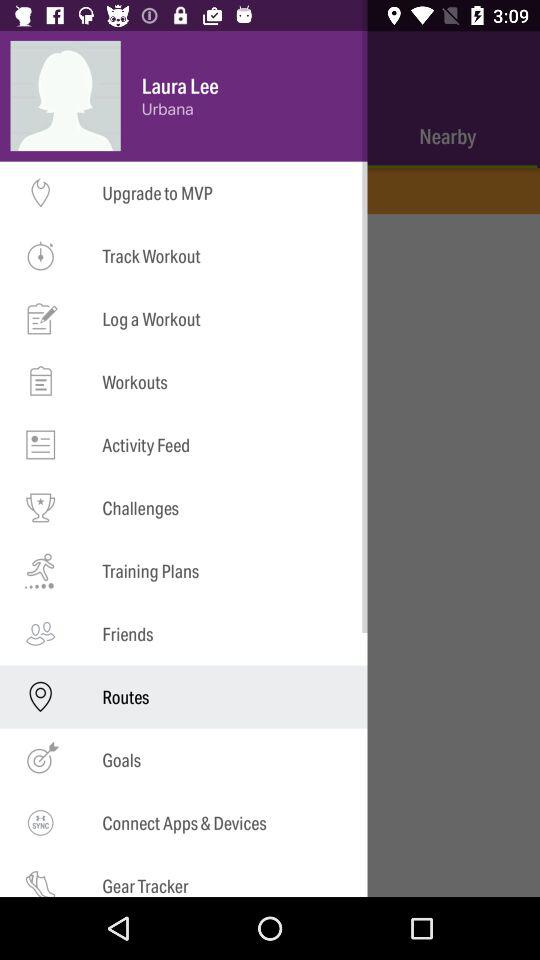What is the location? The location is Urbana. 